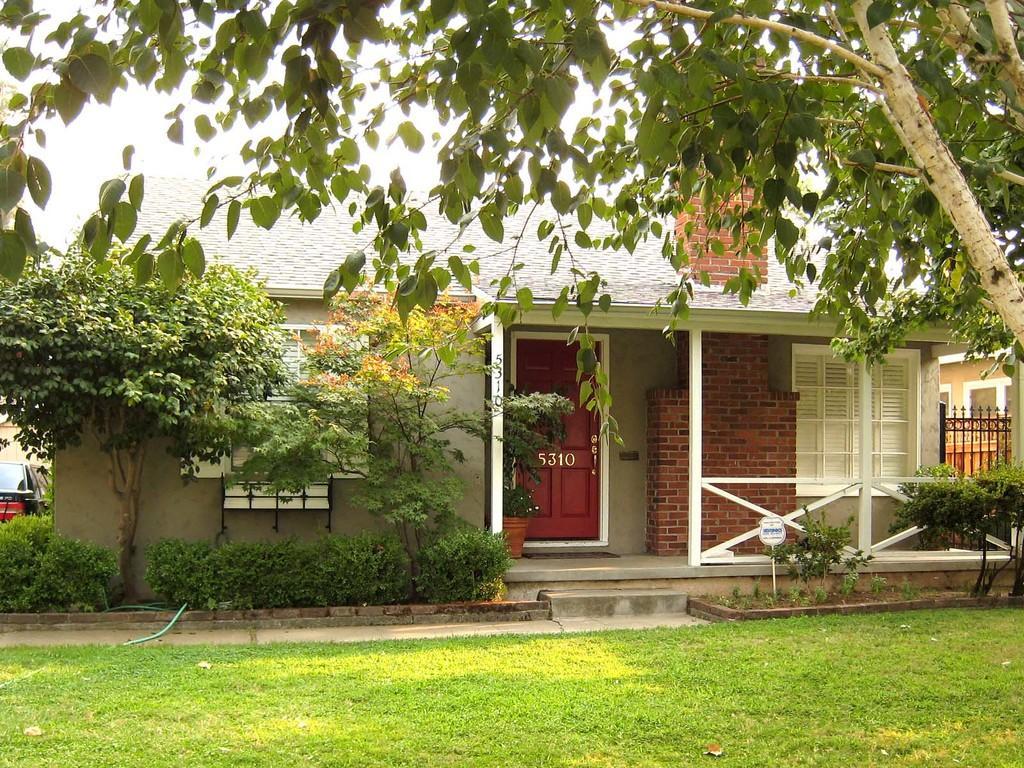Can you describe this image briefly? In this image I see 2 houses and I see a door over here on which there are numbers and I see the windows and I can also see the plants, a car over here, green grass and the trees and I see the fencing over here. 